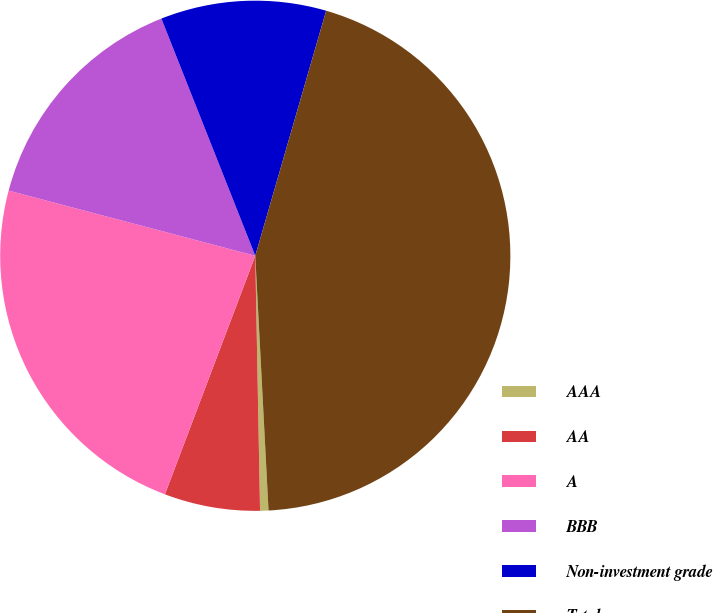Convert chart. <chart><loc_0><loc_0><loc_500><loc_500><pie_chart><fcel>AAA<fcel>AA<fcel>A<fcel>BBB<fcel>Non-investment grade<fcel>Total<nl><fcel>0.53%<fcel>6.06%<fcel>23.35%<fcel>14.89%<fcel>10.48%<fcel>44.69%<nl></chart> 